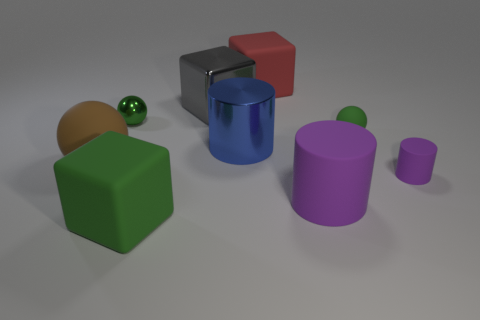Subtract all purple spheres. Subtract all brown cylinders. How many spheres are left? 3 Add 1 large brown metal objects. How many objects exist? 10 Subtract all cubes. How many objects are left? 6 Subtract 0 cyan cylinders. How many objects are left? 9 Subtract all blue things. Subtract all cubes. How many objects are left? 5 Add 6 small purple things. How many small purple things are left? 7 Add 7 cyan shiny cylinders. How many cyan shiny cylinders exist? 7 